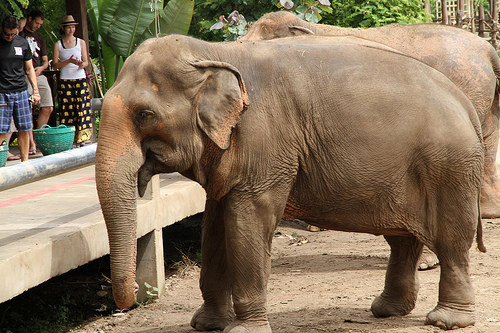That floor is in front of what animal? The floor is in front of an elephant. 